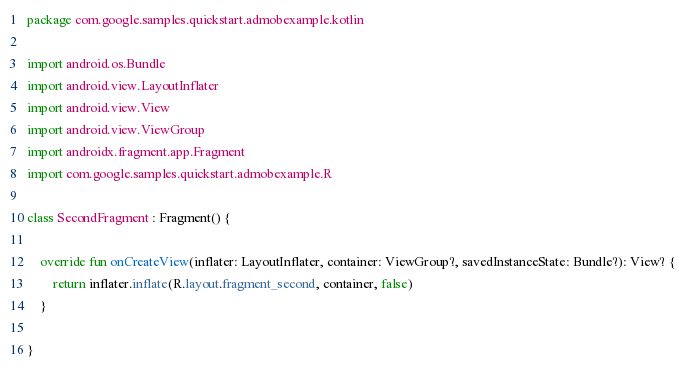<code> <loc_0><loc_0><loc_500><loc_500><_Kotlin_>package com.google.samples.quickstart.admobexample.kotlin

import android.os.Bundle
import android.view.LayoutInflater
import android.view.View
import android.view.ViewGroup
import androidx.fragment.app.Fragment
import com.google.samples.quickstart.admobexample.R

class SecondFragment : Fragment() {

    override fun onCreateView(inflater: LayoutInflater, container: ViewGroup?, savedInstanceState: Bundle?): View? {
        return inflater.inflate(R.layout.fragment_second, container, false)
    }

}</code> 